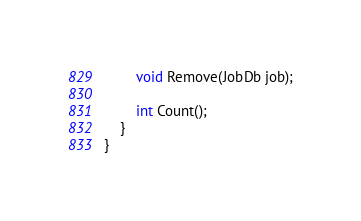Convert code to text. <code><loc_0><loc_0><loc_500><loc_500><_C#_>
        void Remove(JobDb job);

        int Count();
    }
}</code> 